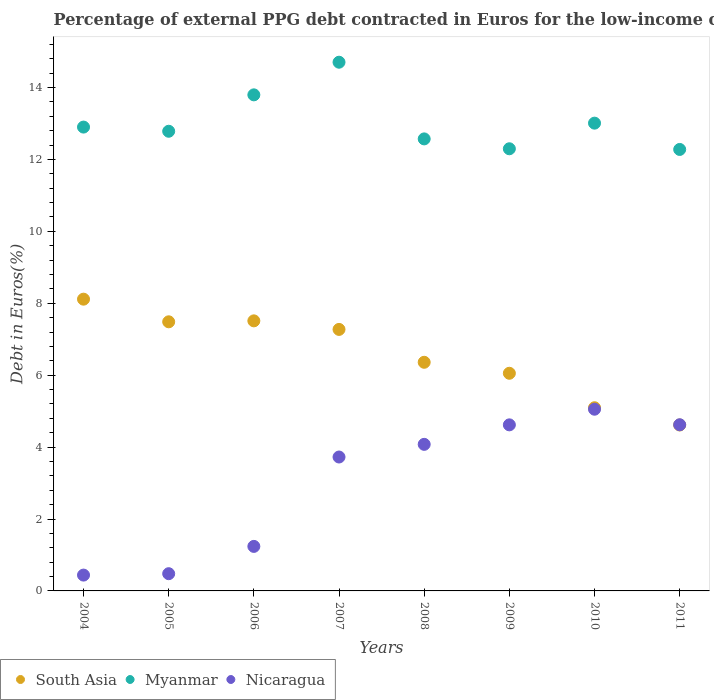What is the percentage of external PPG debt contracted in Euros in South Asia in 2007?
Provide a succinct answer. 7.27. Across all years, what is the maximum percentage of external PPG debt contracted in Euros in Nicaragua?
Give a very brief answer. 5.05. Across all years, what is the minimum percentage of external PPG debt contracted in Euros in Nicaragua?
Your answer should be compact. 0.44. What is the total percentage of external PPG debt contracted in Euros in Nicaragua in the graph?
Provide a short and direct response. 24.25. What is the difference between the percentage of external PPG debt contracted in Euros in Myanmar in 2005 and that in 2007?
Give a very brief answer. -1.92. What is the difference between the percentage of external PPG debt contracted in Euros in Nicaragua in 2011 and the percentage of external PPG debt contracted in Euros in Myanmar in 2009?
Keep it short and to the point. -7.67. What is the average percentage of external PPG debt contracted in Euros in Nicaragua per year?
Provide a short and direct response. 3.03. In the year 2009, what is the difference between the percentage of external PPG debt contracted in Euros in Nicaragua and percentage of external PPG debt contracted in Euros in Myanmar?
Ensure brevity in your answer.  -7.68. In how many years, is the percentage of external PPG debt contracted in Euros in Myanmar greater than 14.4 %?
Make the answer very short. 1. What is the ratio of the percentage of external PPG debt contracted in Euros in South Asia in 2004 to that in 2008?
Give a very brief answer. 1.28. What is the difference between the highest and the second highest percentage of external PPG debt contracted in Euros in Myanmar?
Provide a short and direct response. 0.91. What is the difference between the highest and the lowest percentage of external PPG debt contracted in Euros in Nicaragua?
Offer a terse response. 4.61. In how many years, is the percentage of external PPG debt contracted in Euros in Nicaragua greater than the average percentage of external PPG debt contracted in Euros in Nicaragua taken over all years?
Your response must be concise. 5. Does the percentage of external PPG debt contracted in Euros in South Asia monotonically increase over the years?
Your answer should be compact. No. Is the percentage of external PPG debt contracted in Euros in Myanmar strictly greater than the percentage of external PPG debt contracted in Euros in South Asia over the years?
Give a very brief answer. Yes. How many dotlines are there?
Provide a short and direct response. 3. How many years are there in the graph?
Make the answer very short. 8. Does the graph contain any zero values?
Your answer should be very brief. No. Where does the legend appear in the graph?
Give a very brief answer. Bottom left. How are the legend labels stacked?
Your response must be concise. Horizontal. What is the title of the graph?
Provide a short and direct response. Percentage of external PPG debt contracted in Euros for the low-income countries. What is the label or title of the X-axis?
Make the answer very short. Years. What is the label or title of the Y-axis?
Your response must be concise. Debt in Euros(%). What is the Debt in Euros(%) of South Asia in 2004?
Offer a very short reply. 8.11. What is the Debt in Euros(%) of Myanmar in 2004?
Offer a very short reply. 12.9. What is the Debt in Euros(%) in Nicaragua in 2004?
Keep it short and to the point. 0.44. What is the Debt in Euros(%) of South Asia in 2005?
Ensure brevity in your answer.  7.48. What is the Debt in Euros(%) of Myanmar in 2005?
Ensure brevity in your answer.  12.78. What is the Debt in Euros(%) in Nicaragua in 2005?
Your answer should be very brief. 0.48. What is the Debt in Euros(%) in South Asia in 2006?
Provide a succinct answer. 7.51. What is the Debt in Euros(%) of Myanmar in 2006?
Provide a succinct answer. 13.8. What is the Debt in Euros(%) of Nicaragua in 2006?
Provide a short and direct response. 1.24. What is the Debt in Euros(%) in South Asia in 2007?
Make the answer very short. 7.27. What is the Debt in Euros(%) in Myanmar in 2007?
Offer a very short reply. 14.7. What is the Debt in Euros(%) in Nicaragua in 2007?
Provide a succinct answer. 3.72. What is the Debt in Euros(%) of South Asia in 2008?
Provide a short and direct response. 6.36. What is the Debt in Euros(%) of Myanmar in 2008?
Make the answer very short. 12.57. What is the Debt in Euros(%) in Nicaragua in 2008?
Offer a very short reply. 4.08. What is the Debt in Euros(%) of South Asia in 2009?
Provide a succinct answer. 6.05. What is the Debt in Euros(%) in Myanmar in 2009?
Offer a very short reply. 12.3. What is the Debt in Euros(%) in Nicaragua in 2009?
Keep it short and to the point. 4.62. What is the Debt in Euros(%) in South Asia in 2010?
Your answer should be compact. 5.09. What is the Debt in Euros(%) of Myanmar in 2010?
Make the answer very short. 13.01. What is the Debt in Euros(%) of Nicaragua in 2010?
Give a very brief answer. 5.05. What is the Debt in Euros(%) in South Asia in 2011?
Ensure brevity in your answer.  4.61. What is the Debt in Euros(%) in Myanmar in 2011?
Your answer should be very brief. 12.28. What is the Debt in Euros(%) of Nicaragua in 2011?
Ensure brevity in your answer.  4.62. Across all years, what is the maximum Debt in Euros(%) in South Asia?
Provide a succinct answer. 8.11. Across all years, what is the maximum Debt in Euros(%) in Myanmar?
Ensure brevity in your answer.  14.7. Across all years, what is the maximum Debt in Euros(%) of Nicaragua?
Offer a terse response. 5.05. Across all years, what is the minimum Debt in Euros(%) in South Asia?
Provide a succinct answer. 4.61. Across all years, what is the minimum Debt in Euros(%) in Myanmar?
Make the answer very short. 12.28. Across all years, what is the minimum Debt in Euros(%) in Nicaragua?
Make the answer very short. 0.44. What is the total Debt in Euros(%) in South Asia in the graph?
Keep it short and to the point. 52.5. What is the total Debt in Euros(%) in Myanmar in the graph?
Give a very brief answer. 104.33. What is the total Debt in Euros(%) of Nicaragua in the graph?
Ensure brevity in your answer.  24.25. What is the difference between the Debt in Euros(%) in South Asia in 2004 and that in 2005?
Your answer should be compact. 0.63. What is the difference between the Debt in Euros(%) in Myanmar in 2004 and that in 2005?
Offer a terse response. 0.12. What is the difference between the Debt in Euros(%) of Nicaragua in 2004 and that in 2005?
Offer a very short reply. -0.04. What is the difference between the Debt in Euros(%) in South Asia in 2004 and that in 2006?
Your answer should be compact. 0.6. What is the difference between the Debt in Euros(%) of Myanmar in 2004 and that in 2006?
Offer a very short reply. -0.9. What is the difference between the Debt in Euros(%) of Nicaragua in 2004 and that in 2006?
Make the answer very short. -0.8. What is the difference between the Debt in Euros(%) in South Asia in 2004 and that in 2007?
Offer a terse response. 0.84. What is the difference between the Debt in Euros(%) in Myanmar in 2004 and that in 2007?
Ensure brevity in your answer.  -1.8. What is the difference between the Debt in Euros(%) in Nicaragua in 2004 and that in 2007?
Your answer should be very brief. -3.28. What is the difference between the Debt in Euros(%) of South Asia in 2004 and that in 2008?
Provide a succinct answer. 1.76. What is the difference between the Debt in Euros(%) in Myanmar in 2004 and that in 2008?
Your response must be concise. 0.33. What is the difference between the Debt in Euros(%) in Nicaragua in 2004 and that in 2008?
Offer a very short reply. -3.64. What is the difference between the Debt in Euros(%) in South Asia in 2004 and that in 2009?
Make the answer very short. 2.06. What is the difference between the Debt in Euros(%) in Myanmar in 2004 and that in 2009?
Provide a succinct answer. 0.6. What is the difference between the Debt in Euros(%) of Nicaragua in 2004 and that in 2009?
Give a very brief answer. -4.18. What is the difference between the Debt in Euros(%) of South Asia in 2004 and that in 2010?
Offer a terse response. 3.02. What is the difference between the Debt in Euros(%) in Myanmar in 2004 and that in 2010?
Your response must be concise. -0.11. What is the difference between the Debt in Euros(%) in Nicaragua in 2004 and that in 2010?
Give a very brief answer. -4.61. What is the difference between the Debt in Euros(%) of South Asia in 2004 and that in 2011?
Provide a succinct answer. 3.5. What is the difference between the Debt in Euros(%) of Myanmar in 2004 and that in 2011?
Keep it short and to the point. 0.62. What is the difference between the Debt in Euros(%) in Nicaragua in 2004 and that in 2011?
Provide a succinct answer. -4.18. What is the difference between the Debt in Euros(%) in South Asia in 2005 and that in 2006?
Your answer should be very brief. -0.03. What is the difference between the Debt in Euros(%) of Myanmar in 2005 and that in 2006?
Provide a succinct answer. -1.01. What is the difference between the Debt in Euros(%) in Nicaragua in 2005 and that in 2006?
Your response must be concise. -0.76. What is the difference between the Debt in Euros(%) in South Asia in 2005 and that in 2007?
Provide a short and direct response. 0.21. What is the difference between the Debt in Euros(%) in Myanmar in 2005 and that in 2007?
Keep it short and to the point. -1.92. What is the difference between the Debt in Euros(%) in Nicaragua in 2005 and that in 2007?
Ensure brevity in your answer.  -3.24. What is the difference between the Debt in Euros(%) in South Asia in 2005 and that in 2008?
Offer a terse response. 1.13. What is the difference between the Debt in Euros(%) in Myanmar in 2005 and that in 2008?
Ensure brevity in your answer.  0.21. What is the difference between the Debt in Euros(%) in Nicaragua in 2005 and that in 2008?
Your answer should be compact. -3.6. What is the difference between the Debt in Euros(%) in South Asia in 2005 and that in 2009?
Keep it short and to the point. 1.43. What is the difference between the Debt in Euros(%) in Myanmar in 2005 and that in 2009?
Your answer should be very brief. 0.49. What is the difference between the Debt in Euros(%) of Nicaragua in 2005 and that in 2009?
Keep it short and to the point. -4.14. What is the difference between the Debt in Euros(%) in South Asia in 2005 and that in 2010?
Make the answer very short. 2.39. What is the difference between the Debt in Euros(%) of Myanmar in 2005 and that in 2010?
Offer a very short reply. -0.23. What is the difference between the Debt in Euros(%) in Nicaragua in 2005 and that in 2010?
Provide a short and direct response. -4.57. What is the difference between the Debt in Euros(%) in South Asia in 2005 and that in 2011?
Make the answer very short. 2.87. What is the difference between the Debt in Euros(%) of Myanmar in 2005 and that in 2011?
Your answer should be compact. 0.51. What is the difference between the Debt in Euros(%) of Nicaragua in 2005 and that in 2011?
Offer a terse response. -4.14. What is the difference between the Debt in Euros(%) in South Asia in 2006 and that in 2007?
Provide a succinct answer. 0.24. What is the difference between the Debt in Euros(%) of Myanmar in 2006 and that in 2007?
Give a very brief answer. -0.91. What is the difference between the Debt in Euros(%) in Nicaragua in 2006 and that in 2007?
Offer a terse response. -2.49. What is the difference between the Debt in Euros(%) in South Asia in 2006 and that in 2008?
Offer a terse response. 1.15. What is the difference between the Debt in Euros(%) in Myanmar in 2006 and that in 2008?
Provide a succinct answer. 1.23. What is the difference between the Debt in Euros(%) in Nicaragua in 2006 and that in 2008?
Provide a succinct answer. -2.84. What is the difference between the Debt in Euros(%) of South Asia in 2006 and that in 2009?
Offer a very short reply. 1.46. What is the difference between the Debt in Euros(%) in Myanmar in 2006 and that in 2009?
Keep it short and to the point. 1.5. What is the difference between the Debt in Euros(%) in Nicaragua in 2006 and that in 2009?
Provide a succinct answer. -3.38. What is the difference between the Debt in Euros(%) in South Asia in 2006 and that in 2010?
Give a very brief answer. 2.42. What is the difference between the Debt in Euros(%) in Myanmar in 2006 and that in 2010?
Keep it short and to the point. 0.79. What is the difference between the Debt in Euros(%) in Nicaragua in 2006 and that in 2010?
Keep it short and to the point. -3.81. What is the difference between the Debt in Euros(%) in South Asia in 2006 and that in 2011?
Ensure brevity in your answer.  2.9. What is the difference between the Debt in Euros(%) in Myanmar in 2006 and that in 2011?
Provide a short and direct response. 1.52. What is the difference between the Debt in Euros(%) in Nicaragua in 2006 and that in 2011?
Your answer should be compact. -3.38. What is the difference between the Debt in Euros(%) in South Asia in 2007 and that in 2008?
Provide a short and direct response. 0.91. What is the difference between the Debt in Euros(%) of Myanmar in 2007 and that in 2008?
Your answer should be compact. 2.13. What is the difference between the Debt in Euros(%) of Nicaragua in 2007 and that in 2008?
Give a very brief answer. -0.35. What is the difference between the Debt in Euros(%) in South Asia in 2007 and that in 2009?
Give a very brief answer. 1.22. What is the difference between the Debt in Euros(%) in Myanmar in 2007 and that in 2009?
Offer a very short reply. 2.41. What is the difference between the Debt in Euros(%) of Nicaragua in 2007 and that in 2009?
Make the answer very short. -0.89. What is the difference between the Debt in Euros(%) of South Asia in 2007 and that in 2010?
Make the answer very short. 2.18. What is the difference between the Debt in Euros(%) in Myanmar in 2007 and that in 2010?
Your response must be concise. 1.69. What is the difference between the Debt in Euros(%) of Nicaragua in 2007 and that in 2010?
Provide a short and direct response. -1.33. What is the difference between the Debt in Euros(%) of South Asia in 2007 and that in 2011?
Your answer should be very brief. 2.66. What is the difference between the Debt in Euros(%) in Myanmar in 2007 and that in 2011?
Keep it short and to the point. 2.43. What is the difference between the Debt in Euros(%) in Nicaragua in 2007 and that in 2011?
Provide a succinct answer. -0.9. What is the difference between the Debt in Euros(%) of South Asia in 2008 and that in 2009?
Provide a succinct answer. 0.31. What is the difference between the Debt in Euros(%) in Myanmar in 2008 and that in 2009?
Offer a terse response. 0.27. What is the difference between the Debt in Euros(%) of Nicaragua in 2008 and that in 2009?
Provide a short and direct response. -0.54. What is the difference between the Debt in Euros(%) of South Asia in 2008 and that in 2010?
Provide a short and direct response. 1.26. What is the difference between the Debt in Euros(%) in Myanmar in 2008 and that in 2010?
Your answer should be very brief. -0.44. What is the difference between the Debt in Euros(%) in Nicaragua in 2008 and that in 2010?
Give a very brief answer. -0.98. What is the difference between the Debt in Euros(%) of South Asia in 2008 and that in 2011?
Provide a short and direct response. 1.74. What is the difference between the Debt in Euros(%) in Myanmar in 2008 and that in 2011?
Give a very brief answer. 0.29. What is the difference between the Debt in Euros(%) in Nicaragua in 2008 and that in 2011?
Offer a terse response. -0.54. What is the difference between the Debt in Euros(%) of South Asia in 2009 and that in 2010?
Ensure brevity in your answer.  0.96. What is the difference between the Debt in Euros(%) in Myanmar in 2009 and that in 2010?
Offer a very short reply. -0.71. What is the difference between the Debt in Euros(%) in Nicaragua in 2009 and that in 2010?
Your response must be concise. -0.43. What is the difference between the Debt in Euros(%) in South Asia in 2009 and that in 2011?
Offer a terse response. 1.44. What is the difference between the Debt in Euros(%) in Myanmar in 2009 and that in 2011?
Offer a terse response. 0.02. What is the difference between the Debt in Euros(%) in Nicaragua in 2009 and that in 2011?
Your answer should be compact. -0. What is the difference between the Debt in Euros(%) of South Asia in 2010 and that in 2011?
Give a very brief answer. 0.48. What is the difference between the Debt in Euros(%) of Myanmar in 2010 and that in 2011?
Provide a succinct answer. 0.73. What is the difference between the Debt in Euros(%) of Nicaragua in 2010 and that in 2011?
Ensure brevity in your answer.  0.43. What is the difference between the Debt in Euros(%) of South Asia in 2004 and the Debt in Euros(%) of Myanmar in 2005?
Give a very brief answer. -4.67. What is the difference between the Debt in Euros(%) in South Asia in 2004 and the Debt in Euros(%) in Nicaragua in 2005?
Your answer should be very brief. 7.63. What is the difference between the Debt in Euros(%) in Myanmar in 2004 and the Debt in Euros(%) in Nicaragua in 2005?
Keep it short and to the point. 12.42. What is the difference between the Debt in Euros(%) of South Asia in 2004 and the Debt in Euros(%) of Myanmar in 2006?
Offer a very short reply. -5.68. What is the difference between the Debt in Euros(%) of South Asia in 2004 and the Debt in Euros(%) of Nicaragua in 2006?
Your answer should be very brief. 6.88. What is the difference between the Debt in Euros(%) in Myanmar in 2004 and the Debt in Euros(%) in Nicaragua in 2006?
Your response must be concise. 11.66. What is the difference between the Debt in Euros(%) of South Asia in 2004 and the Debt in Euros(%) of Myanmar in 2007?
Ensure brevity in your answer.  -6.59. What is the difference between the Debt in Euros(%) of South Asia in 2004 and the Debt in Euros(%) of Nicaragua in 2007?
Provide a short and direct response. 4.39. What is the difference between the Debt in Euros(%) of Myanmar in 2004 and the Debt in Euros(%) of Nicaragua in 2007?
Offer a terse response. 9.18. What is the difference between the Debt in Euros(%) in South Asia in 2004 and the Debt in Euros(%) in Myanmar in 2008?
Make the answer very short. -4.46. What is the difference between the Debt in Euros(%) of South Asia in 2004 and the Debt in Euros(%) of Nicaragua in 2008?
Provide a succinct answer. 4.04. What is the difference between the Debt in Euros(%) of Myanmar in 2004 and the Debt in Euros(%) of Nicaragua in 2008?
Provide a succinct answer. 8.82. What is the difference between the Debt in Euros(%) in South Asia in 2004 and the Debt in Euros(%) in Myanmar in 2009?
Offer a terse response. -4.18. What is the difference between the Debt in Euros(%) of South Asia in 2004 and the Debt in Euros(%) of Nicaragua in 2009?
Your answer should be very brief. 3.5. What is the difference between the Debt in Euros(%) of Myanmar in 2004 and the Debt in Euros(%) of Nicaragua in 2009?
Your answer should be very brief. 8.28. What is the difference between the Debt in Euros(%) in South Asia in 2004 and the Debt in Euros(%) in Myanmar in 2010?
Provide a succinct answer. -4.89. What is the difference between the Debt in Euros(%) in South Asia in 2004 and the Debt in Euros(%) in Nicaragua in 2010?
Provide a short and direct response. 3.06. What is the difference between the Debt in Euros(%) of Myanmar in 2004 and the Debt in Euros(%) of Nicaragua in 2010?
Your answer should be compact. 7.85. What is the difference between the Debt in Euros(%) of South Asia in 2004 and the Debt in Euros(%) of Myanmar in 2011?
Provide a short and direct response. -4.16. What is the difference between the Debt in Euros(%) of South Asia in 2004 and the Debt in Euros(%) of Nicaragua in 2011?
Keep it short and to the point. 3.49. What is the difference between the Debt in Euros(%) of Myanmar in 2004 and the Debt in Euros(%) of Nicaragua in 2011?
Keep it short and to the point. 8.28. What is the difference between the Debt in Euros(%) in South Asia in 2005 and the Debt in Euros(%) in Myanmar in 2006?
Provide a succinct answer. -6.31. What is the difference between the Debt in Euros(%) in South Asia in 2005 and the Debt in Euros(%) in Nicaragua in 2006?
Make the answer very short. 6.25. What is the difference between the Debt in Euros(%) in Myanmar in 2005 and the Debt in Euros(%) in Nicaragua in 2006?
Your response must be concise. 11.54. What is the difference between the Debt in Euros(%) of South Asia in 2005 and the Debt in Euros(%) of Myanmar in 2007?
Keep it short and to the point. -7.22. What is the difference between the Debt in Euros(%) in South Asia in 2005 and the Debt in Euros(%) in Nicaragua in 2007?
Offer a very short reply. 3.76. What is the difference between the Debt in Euros(%) of Myanmar in 2005 and the Debt in Euros(%) of Nicaragua in 2007?
Provide a short and direct response. 9.06. What is the difference between the Debt in Euros(%) in South Asia in 2005 and the Debt in Euros(%) in Myanmar in 2008?
Keep it short and to the point. -5.09. What is the difference between the Debt in Euros(%) of South Asia in 2005 and the Debt in Euros(%) of Nicaragua in 2008?
Provide a succinct answer. 3.41. What is the difference between the Debt in Euros(%) of Myanmar in 2005 and the Debt in Euros(%) of Nicaragua in 2008?
Offer a terse response. 8.71. What is the difference between the Debt in Euros(%) in South Asia in 2005 and the Debt in Euros(%) in Myanmar in 2009?
Your answer should be very brief. -4.81. What is the difference between the Debt in Euros(%) of South Asia in 2005 and the Debt in Euros(%) of Nicaragua in 2009?
Offer a terse response. 2.87. What is the difference between the Debt in Euros(%) of Myanmar in 2005 and the Debt in Euros(%) of Nicaragua in 2009?
Your response must be concise. 8.16. What is the difference between the Debt in Euros(%) in South Asia in 2005 and the Debt in Euros(%) in Myanmar in 2010?
Make the answer very short. -5.52. What is the difference between the Debt in Euros(%) of South Asia in 2005 and the Debt in Euros(%) of Nicaragua in 2010?
Provide a short and direct response. 2.43. What is the difference between the Debt in Euros(%) of Myanmar in 2005 and the Debt in Euros(%) of Nicaragua in 2010?
Give a very brief answer. 7.73. What is the difference between the Debt in Euros(%) in South Asia in 2005 and the Debt in Euros(%) in Myanmar in 2011?
Ensure brevity in your answer.  -4.79. What is the difference between the Debt in Euros(%) of South Asia in 2005 and the Debt in Euros(%) of Nicaragua in 2011?
Keep it short and to the point. 2.86. What is the difference between the Debt in Euros(%) of Myanmar in 2005 and the Debt in Euros(%) of Nicaragua in 2011?
Keep it short and to the point. 8.16. What is the difference between the Debt in Euros(%) in South Asia in 2006 and the Debt in Euros(%) in Myanmar in 2007?
Offer a very short reply. -7.19. What is the difference between the Debt in Euros(%) of South Asia in 2006 and the Debt in Euros(%) of Nicaragua in 2007?
Provide a short and direct response. 3.79. What is the difference between the Debt in Euros(%) in Myanmar in 2006 and the Debt in Euros(%) in Nicaragua in 2007?
Your answer should be very brief. 10.07. What is the difference between the Debt in Euros(%) in South Asia in 2006 and the Debt in Euros(%) in Myanmar in 2008?
Make the answer very short. -5.06. What is the difference between the Debt in Euros(%) in South Asia in 2006 and the Debt in Euros(%) in Nicaragua in 2008?
Provide a succinct answer. 3.43. What is the difference between the Debt in Euros(%) of Myanmar in 2006 and the Debt in Euros(%) of Nicaragua in 2008?
Offer a very short reply. 9.72. What is the difference between the Debt in Euros(%) of South Asia in 2006 and the Debt in Euros(%) of Myanmar in 2009?
Offer a terse response. -4.79. What is the difference between the Debt in Euros(%) in South Asia in 2006 and the Debt in Euros(%) in Nicaragua in 2009?
Offer a very short reply. 2.89. What is the difference between the Debt in Euros(%) of Myanmar in 2006 and the Debt in Euros(%) of Nicaragua in 2009?
Your answer should be compact. 9.18. What is the difference between the Debt in Euros(%) of South Asia in 2006 and the Debt in Euros(%) of Myanmar in 2010?
Your response must be concise. -5.5. What is the difference between the Debt in Euros(%) in South Asia in 2006 and the Debt in Euros(%) in Nicaragua in 2010?
Provide a short and direct response. 2.46. What is the difference between the Debt in Euros(%) of Myanmar in 2006 and the Debt in Euros(%) of Nicaragua in 2010?
Your answer should be very brief. 8.74. What is the difference between the Debt in Euros(%) in South Asia in 2006 and the Debt in Euros(%) in Myanmar in 2011?
Make the answer very short. -4.77. What is the difference between the Debt in Euros(%) of South Asia in 2006 and the Debt in Euros(%) of Nicaragua in 2011?
Your answer should be compact. 2.89. What is the difference between the Debt in Euros(%) in Myanmar in 2006 and the Debt in Euros(%) in Nicaragua in 2011?
Make the answer very short. 9.17. What is the difference between the Debt in Euros(%) in South Asia in 2007 and the Debt in Euros(%) in Myanmar in 2008?
Offer a very short reply. -5.3. What is the difference between the Debt in Euros(%) in South Asia in 2007 and the Debt in Euros(%) in Nicaragua in 2008?
Your answer should be compact. 3.2. What is the difference between the Debt in Euros(%) in Myanmar in 2007 and the Debt in Euros(%) in Nicaragua in 2008?
Your answer should be very brief. 10.63. What is the difference between the Debt in Euros(%) in South Asia in 2007 and the Debt in Euros(%) in Myanmar in 2009?
Give a very brief answer. -5.02. What is the difference between the Debt in Euros(%) of South Asia in 2007 and the Debt in Euros(%) of Nicaragua in 2009?
Offer a very short reply. 2.65. What is the difference between the Debt in Euros(%) of Myanmar in 2007 and the Debt in Euros(%) of Nicaragua in 2009?
Make the answer very short. 10.08. What is the difference between the Debt in Euros(%) in South Asia in 2007 and the Debt in Euros(%) in Myanmar in 2010?
Ensure brevity in your answer.  -5.74. What is the difference between the Debt in Euros(%) of South Asia in 2007 and the Debt in Euros(%) of Nicaragua in 2010?
Make the answer very short. 2.22. What is the difference between the Debt in Euros(%) of Myanmar in 2007 and the Debt in Euros(%) of Nicaragua in 2010?
Your answer should be very brief. 9.65. What is the difference between the Debt in Euros(%) of South Asia in 2007 and the Debt in Euros(%) of Myanmar in 2011?
Make the answer very short. -5. What is the difference between the Debt in Euros(%) in South Asia in 2007 and the Debt in Euros(%) in Nicaragua in 2011?
Your answer should be compact. 2.65. What is the difference between the Debt in Euros(%) in Myanmar in 2007 and the Debt in Euros(%) in Nicaragua in 2011?
Give a very brief answer. 10.08. What is the difference between the Debt in Euros(%) of South Asia in 2008 and the Debt in Euros(%) of Myanmar in 2009?
Keep it short and to the point. -5.94. What is the difference between the Debt in Euros(%) of South Asia in 2008 and the Debt in Euros(%) of Nicaragua in 2009?
Ensure brevity in your answer.  1.74. What is the difference between the Debt in Euros(%) of Myanmar in 2008 and the Debt in Euros(%) of Nicaragua in 2009?
Make the answer very short. 7.95. What is the difference between the Debt in Euros(%) in South Asia in 2008 and the Debt in Euros(%) in Myanmar in 2010?
Provide a short and direct response. -6.65. What is the difference between the Debt in Euros(%) of South Asia in 2008 and the Debt in Euros(%) of Nicaragua in 2010?
Offer a terse response. 1.31. What is the difference between the Debt in Euros(%) in Myanmar in 2008 and the Debt in Euros(%) in Nicaragua in 2010?
Give a very brief answer. 7.52. What is the difference between the Debt in Euros(%) of South Asia in 2008 and the Debt in Euros(%) of Myanmar in 2011?
Offer a very short reply. -5.92. What is the difference between the Debt in Euros(%) in South Asia in 2008 and the Debt in Euros(%) in Nicaragua in 2011?
Your answer should be very brief. 1.74. What is the difference between the Debt in Euros(%) in Myanmar in 2008 and the Debt in Euros(%) in Nicaragua in 2011?
Provide a succinct answer. 7.95. What is the difference between the Debt in Euros(%) in South Asia in 2009 and the Debt in Euros(%) in Myanmar in 2010?
Provide a short and direct response. -6.96. What is the difference between the Debt in Euros(%) of South Asia in 2009 and the Debt in Euros(%) of Nicaragua in 2010?
Provide a succinct answer. 1. What is the difference between the Debt in Euros(%) in Myanmar in 2009 and the Debt in Euros(%) in Nicaragua in 2010?
Ensure brevity in your answer.  7.24. What is the difference between the Debt in Euros(%) in South Asia in 2009 and the Debt in Euros(%) in Myanmar in 2011?
Your response must be concise. -6.22. What is the difference between the Debt in Euros(%) in South Asia in 2009 and the Debt in Euros(%) in Nicaragua in 2011?
Provide a short and direct response. 1.43. What is the difference between the Debt in Euros(%) of Myanmar in 2009 and the Debt in Euros(%) of Nicaragua in 2011?
Provide a short and direct response. 7.67. What is the difference between the Debt in Euros(%) of South Asia in 2010 and the Debt in Euros(%) of Myanmar in 2011?
Provide a succinct answer. -7.18. What is the difference between the Debt in Euros(%) in South Asia in 2010 and the Debt in Euros(%) in Nicaragua in 2011?
Your response must be concise. 0.47. What is the difference between the Debt in Euros(%) of Myanmar in 2010 and the Debt in Euros(%) of Nicaragua in 2011?
Give a very brief answer. 8.39. What is the average Debt in Euros(%) of South Asia per year?
Keep it short and to the point. 6.56. What is the average Debt in Euros(%) in Myanmar per year?
Offer a terse response. 13.04. What is the average Debt in Euros(%) of Nicaragua per year?
Offer a terse response. 3.03. In the year 2004, what is the difference between the Debt in Euros(%) of South Asia and Debt in Euros(%) of Myanmar?
Offer a terse response. -4.79. In the year 2004, what is the difference between the Debt in Euros(%) in South Asia and Debt in Euros(%) in Nicaragua?
Make the answer very short. 7.67. In the year 2004, what is the difference between the Debt in Euros(%) of Myanmar and Debt in Euros(%) of Nicaragua?
Keep it short and to the point. 12.46. In the year 2005, what is the difference between the Debt in Euros(%) of South Asia and Debt in Euros(%) of Myanmar?
Ensure brevity in your answer.  -5.3. In the year 2005, what is the difference between the Debt in Euros(%) of South Asia and Debt in Euros(%) of Nicaragua?
Your answer should be compact. 7. In the year 2005, what is the difference between the Debt in Euros(%) in Myanmar and Debt in Euros(%) in Nicaragua?
Provide a short and direct response. 12.3. In the year 2006, what is the difference between the Debt in Euros(%) in South Asia and Debt in Euros(%) in Myanmar?
Provide a short and direct response. -6.29. In the year 2006, what is the difference between the Debt in Euros(%) of South Asia and Debt in Euros(%) of Nicaragua?
Your answer should be compact. 6.27. In the year 2006, what is the difference between the Debt in Euros(%) of Myanmar and Debt in Euros(%) of Nicaragua?
Give a very brief answer. 12.56. In the year 2007, what is the difference between the Debt in Euros(%) of South Asia and Debt in Euros(%) of Myanmar?
Keep it short and to the point. -7.43. In the year 2007, what is the difference between the Debt in Euros(%) of South Asia and Debt in Euros(%) of Nicaragua?
Keep it short and to the point. 3.55. In the year 2007, what is the difference between the Debt in Euros(%) of Myanmar and Debt in Euros(%) of Nicaragua?
Ensure brevity in your answer.  10.98. In the year 2008, what is the difference between the Debt in Euros(%) of South Asia and Debt in Euros(%) of Myanmar?
Offer a terse response. -6.21. In the year 2008, what is the difference between the Debt in Euros(%) in South Asia and Debt in Euros(%) in Nicaragua?
Keep it short and to the point. 2.28. In the year 2008, what is the difference between the Debt in Euros(%) in Myanmar and Debt in Euros(%) in Nicaragua?
Ensure brevity in your answer.  8.49. In the year 2009, what is the difference between the Debt in Euros(%) in South Asia and Debt in Euros(%) in Myanmar?
Your answer should be compact. -6.24. In the year 2009, what is the difference between the Debt in Euros(%) in South Asia and Debt in Euros(%) in Nicaragua?
Ensure brevity in your answer.  1.43. In the year 2009, what is the difference between the Debt in Euros(%) in Myanmar and Debt in Euros(%) in Nicaragua?
Your response must be concise. 7.68. In the year 2010, what is the difference between the Debt in Euros(%) of South Asia and Debt in Euros(%) of Myanmar?
Keep it short and to the point. -7.91. In the year 2010, what is the difference between the Debt in Euros(%) of South Asia and Debt in Euros(%) of Nicaragua?
Provide a succinct answer. 0.04. In the year 2010, what is the difference between the Debt in Euros(%) of Myanmar and Debt in Euros(%) of Nicaragua?
Provide a succinct answer. 7.96. In the year 2011, what is the difference between the Debt in Euros(%) in South Asia and Debt in Euros(%) in Myanmar?
Offer a very short reply. -7.66. In the year 2011, what is the difference between the Debt in Euros(%) in South Asia and Debt in Euros(%) in Nicaragua?
Your answer should be compact. -0.01. In the year 2011, what is the difference between the Debt in Euros(%) in Myanmar and Debt in Euros(%) in Nicaragua?
Offer a terse response. 7.66. What is the ratio of the Debt in Euros(%) of South Asia in 2004 to that in 2005?
Keep it short and to the point. 1.08. What is the ratio of the Debt in Euros(%) in Myanmar in 2004 to that in 2005?
Provide a short and direct response. 1.01. What is the ratio of the Debt in Euros(%) in Nicaragua in 2004 to that in 2005?
Keep it short and to the point. 0.92. What is the ratio of the Debt in Euros(%) in South Asia in 2004 to that in 2006?
Offer a very short reply. 1.08. What is the ratio of the Debt in Euros(%) in Myanmar in 2004 to that in 2006?
Your answer should be compact. 0.94. What is the ratio of the Debt in Euros(%) of Nicaragua in 2004 to that in 2006?
Ensure brevity in your answer.  0.36. What is the ratio of the Debt in Euros(%) in South Asia in 2004 to that in 2007?
Your response must be concise. 1.12. What is the ratio of the Debt in Euros(%) of Myanmar in 2004 to that in 2007?
Give a very brief answer. 0.88. What is the ratio of the Debt in Euros(%) of Nicaragua in 2004 to that in 2007?
Make the answer very short. 0.12. What is the ratio of the Debt in Euros(%) in South Asia in 2004 to that in 2008?
Keep it short and to the point. 1.28. What is the ratio of the Debt in Euros(%) of Myanmar in 2004 to that in 2008?
Provide a succinct answer. 1.03. What is the ratio of the Debt in Euros(%) in Nicaragua in 2004 to that in 2008?
Your answer should be compact. 0.11. What is the ratio of the Debt in Euros(%) of South Asia in 2004 to that in 2009?
Make the answer very short. 1.34. What is the ratio of the Debt in Euros(%) in Myanmar in 2004 to that in 2009?
Your answer should be very brief. 1.05. What is the ratio of the Debt in Euros(%) in Nicaragua in 2004 to that in 2009?
Give a very brief answer. 0.1. What is the ratio of the Debt in Euros(%) in South Asia in 2004 to that in 2010?
Keep it short and to the point. 1.59. What is the ratio of the Debt in Euros(%) of Myanmar in 2004 to that in 2010?
Offer a very short reply. 0.99. What is the ratio of the Debt in Euros(%) of Nicaragua in 2004 to that in 2010?
Give a very brief answer. 0.09. What is the ratio of the Debt in Euros(%) in South Asia in 2004 to that in 2011?
Keep it short and to the point. 1.76. What is the ratio of the Debt in Euros(%) of Myanmar in 2004 to that in 2011?
Ensure brevity in your answer.  1.05. What is the ratio of the Debt in Euros(%) in Nicaragua in 2004 to that in 2011?
Give a very brief answer. 0.1. What is the ratio of the Debt in Euros(%) in Myanmar in 2005 to that in 2006?
Give a very brief answer. 0.93. What is the ratio of the Debt in Euros(%) in Nicaragua in 2005 to that in 2006?
Provide a short and direct response. 0.39. What is the ratio of the Debt in Euros(%) in South Asia in 2005 to that in 2007?
Keep it short and to the point. 1.03. What is the ratio of the Debt in Euros(%) in Myanmar in 2005 to that in 2007?
Your answer should be very brief. 0.87. What is the ratio of the Debt in Euros(%) of Nicaragua in 2005 to that in 2007?
Offer a very short reply. 0.13. What is the ratio of the Debt in Euros(%) of South Asia in 2005 to that in 2008?
Your answer should be compact. 1.18. What is the ratio of the Debt in Euros(%) of Myanmar in 2005 to that in 2008?
Your answer should be compact. 1.02. What is the ratio of the Debt in Euros(%) in Nicaragua in 2005 to that in 2008?
Offer a terse response. 0.12. What is the ratio of the Debt in Euros(%) in South Asia in 2005 to that in 2009?
Ensure brevity in your answer.  1.24. What is the ratio of the Debt in Euros(%) of Myanmar in 2005 to that in 2009?
Keep it short and to the point. 1.04. What is the ratio of the Debt in Euros(%) of Nicaragua in 2005 to that in 2009?
Your response must be concise. 0.1. What is the ratio of the Debt in Euros(%) in South Asia in 2005 to that in 2010?
Give a very brief answer. 1.47. What is the ratio of the Debt in Euros(%) in Myanmar in 2005 to that in 2010?
Offer a terse response. 0.98. What is the ratio of the Debt in Euros(%) in Nicaragua in 2005 to that in 2010?
Make the answer very short. 0.09. What is the ratio of the Debt in Euros(%) of South Asia in 2005 to that in 2011?
Your answer should be compact. 1.62. What is the ratio of the Debt in Euros(%) in Myanmar in 2005 to that in 2011?
Give a very brief answer. 1.04. What is the ratio of the Debt in Euros(%) in Nicaragua in 2005 to that in 2011?
Make the answer very short. 0.1. What is the ratio of the Debt in Euros(%) in South Asia in 2006 to that in 2007?
Keep it short and to the point. 1.03. What is the ratio of the Debt in Euros(%) in Myanmar in 2006 to that in 2007?
Provide a short and direct response. 0.94. What is the ratio of the Debt in Euros(%) in Nicaragua in 2006 to that in 2007?
Offer a terse response. 0.33. What is the ratio of the Debt in Euros(%) of South Asia in 2006 to that in 2008?
Your answer should be compact. 1.18. What is the ratio of the Debt in Euros(%) in Myanmar in 2006 to that in 2008?
Give a very brief answer. 1.1. What is the ratio of the Debt in Euros(%) of Nicaragua in 2006 to that in 2008?
Make the answer very short. 0.3. What is the ratio of the Debt in Euros(%) of South Asia in 2006 to that in 2009?
Your answer should be very brief. 1.24. What is the ratio of the Debt in Euros(%) of Myanmar in 2006 to that in 2009?
Your response must be concise. 1.12. What is the ratio of the Debt in Euros(%) of Nicaragua in 2006 to that in 2009?
Give a very brief answer. 0.27. What is the ratio of the Debt in Euros(%) of South Asia in 2006 to that in 2010?
Offer a very short reply. 1.47. What is the ratio of the Debt in Euros(%) in Myanmar in 2006 to that in 2010?
Give a very brief answer. 1.06. What is the ratio of the Debt in Euros(%) in Nicaragua in 2006 to that in 2010?
Your answer should be very brief. 0.24. What is the ratio of the Debt in Euros(%) in South Asia in 2006 to that in 2011?
Make the answer very short. 1.63. What is the ratio of the Debt in Euros(%) of Myanmar in 2006 to that in 2011?
Offer a terse response. 1.12. What is the ratio of the Debt in Euros(%) of Nicaragua in 2006 to that in 2011?
Offer a very short reply. 0.27. What is the ratio of the Debt in Euros(%) in South Asia in 2007 to that in 2008?
Your response must be concise. 1.14. What is the ratio of the Debt in Euros(%) in Myanmar in 2007 to that in 2008?
Provide a succinct answer. 1.17. What is the ratio of the Debt in Euros(%) of Nicaragua in 2007 to that in 2008?
Your response must be concise. 0.91. What is the ratio of the Debt in Euros(%) in South Asia in 2007 to that in 2009?
Make the answer very short. 1.2. What is the ratio of the Debt in Euros(%) in Myanmar in 2007 to that in 2009?
Provide a succinct answer. 1.2. What is the ratio of the Debt in Euros(%) in Nicaragua in 2007 to that in 2009?
Make the answer very short. 0.81. What is the ratio of the Debt in Euros(%) in South Asia in 2007 to that in 2010?
Your response must be concise. 1.43. What is the ratio of the Debt in Euros(%) of Myanmar in 2007 to that in 2010?
Provide a succinct answer. 1.13. What is the ratio of the Debt in Euros(%) of Nicaragua in 2007 to that in 2010?
Offer a very short reply. 0.74. What is the ratio of the Debt in Euros(%) in South Asia in 2007 to that in 2011?
Provide a short and direct response. 1.58. What is the ratio of the Debt in Euros(%) in Myanmar in 2007 to that in 2011?
Ensure brevity in your answer.  1.2. What is the ratio of the Debt in Euros(%) in Nicaragua in 2007 to that in 2011?
Provide a short and direct response. 0.81. What is the ratio of the Debt in Euros(%) in South Asia in 2008 to that in 2009?
Offer a very short reply. 1.05. What is the ratio of the Debt in Euros(%) in Myanmar in 2008 to that in 2009?
Keep it short and to the point. 1.02. What is the ratio of the Debt in Euros(%) of Nicaragua in 2008 to that in 2009?
Your response must be concise. 0.88. What is the ratio of the Debt in Euros(%) in South Asia in 2008 to that in 2010?
Ensure brevity in your answer.  1.25. What is the ratio of the Debt in Euros(%) in Myanmar in 2008 to that in 2010?
Your answer should be compact. 0.97. What is the ratio of the Debt in Euros(%) in Nicaragua in 2008 to that in 2010?
Provide a short and direct response. 0.81. What is the ratio of the Debt in Euros(%) in South Asia in 2008 to that in 2011?
Offer a very short reply. 1.38. What is the ratio of the Debt in Euros(%) of Myanmar in 2008 to that in 2011?
Make the answer very short. 1.02. What is the ratio of the Debt in Euros(%) of Nicaragua in 2008 to that in 2011?
Your answer should be very brief. 0.88. What is the ratio of the Debt in Euros(%) of South Asia in 2009 to that in 2010?
Your response must be concise. 1.19. What is the ratio of the Debt in Euros(%) of Myanmar in 2009 to that in 2010?
Your answer should be very brief. 0.95. What is the ratio of the Debt in Euros(%) in Nicaragua in 2009 to that in 2010?
Give a very brief answer. 0.91. What is the ratio of the Debt in Euros(%) in South Asia in 2009 to that in 2011?
Offer a very short reply. 1.31. What is the ratio of the Debt in Euros(%) in Nicaragua in 2009 to that in 2011?
Your answer should be compact. 1. What is the ratio of the Debt in Euros(%) in South Asia in 2010 to that in 2011?
Your response must be concise. 1.1. What is the ratio of the Debt in Euros(%) in Myanmar in 2010 to that in 2011?
Ensure brevity in your answer.  1.06. What is the ratio of the Debt in Euros(%) in Nicaragua in 2010 to that in 2011?
Give a very brief answer. 1.09. What is the difference between the highest and the second highest Debt in Euros(%) in South Asia?
Keep it short and to the point. 0.6. What is the difference between the highest and the second highest Debt in Euros(%) in Myanmar?
Give a very brief answer. 0.91. What is the difference between the highest and the second highest Debt in Euros(%) in Nicaragua?
Keep it short and to the point. 0.43. What is the difference between the highest and the lowest Debt in Euros(%) of South Asia?
Provide a short and direct response. 3.5. What is the difference between the highest and the lowest Debt in Euros(%) in Myanmar?
Provide a short and direct response. 2.43. What is the difference between the highest and the lowest Debt in Euros(%) in Nicaragua?
Your answer should be very brief. 4.61. 